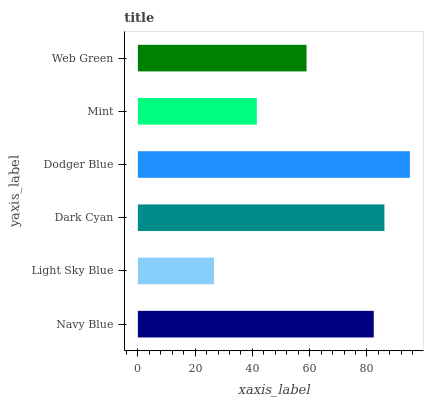Is Light Sky Blue the minimum?
Answer yes or no. Yes. Is Dodger Blue the maximum?
Answer yes or no. Yes. Is Dark Cyan the minimum?
Answer yes or no. No. Is Dark Cyan the maximum?
Answer yes or no. No. Is Dark Cyan greater than Light Sky Blue?
Answer yes or no. Yes. Is Light Sky Blue less than Dark Cyan?
Answer yes or no. Yes. Is Light Sky Blue greater than Dark Cyan?
Answer yes or no. No. Is Dark Cyan less than Light Sky Blue?
Answer yes or no. No. Is Navy Blue the high median?
Answer yes or no. Yes. Is Web Green the low median?
Answer yes or no. Yes. Is Light Sky Blue the high median?
Answer yes or no. No. Is Navy Blue the low median?
Answer yes or no. No. 